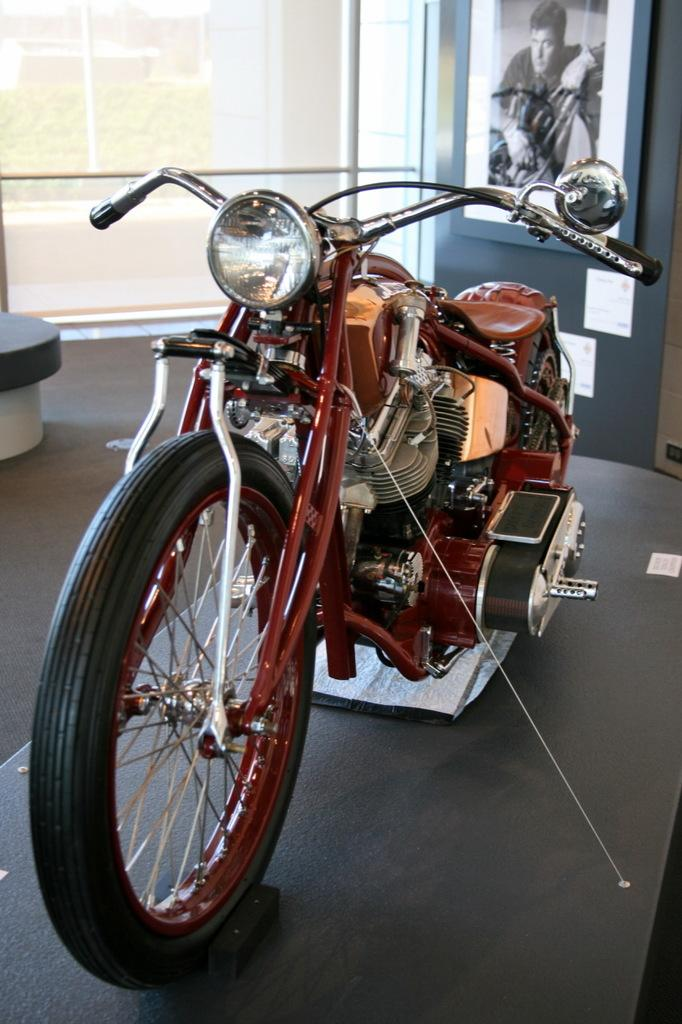What is the main object in the image? There is a bike in the image. What can be seen in the background of the image? There is a glass wall in the background of the image. Are there any additional items or features in the image? Yes, there is a poster in the image. Where is the toothbrush located in the image? There is no toothbrush present in the image. Is the bike on a stage in the image? There is no stage present in the image, and the bike is not on a stage. 